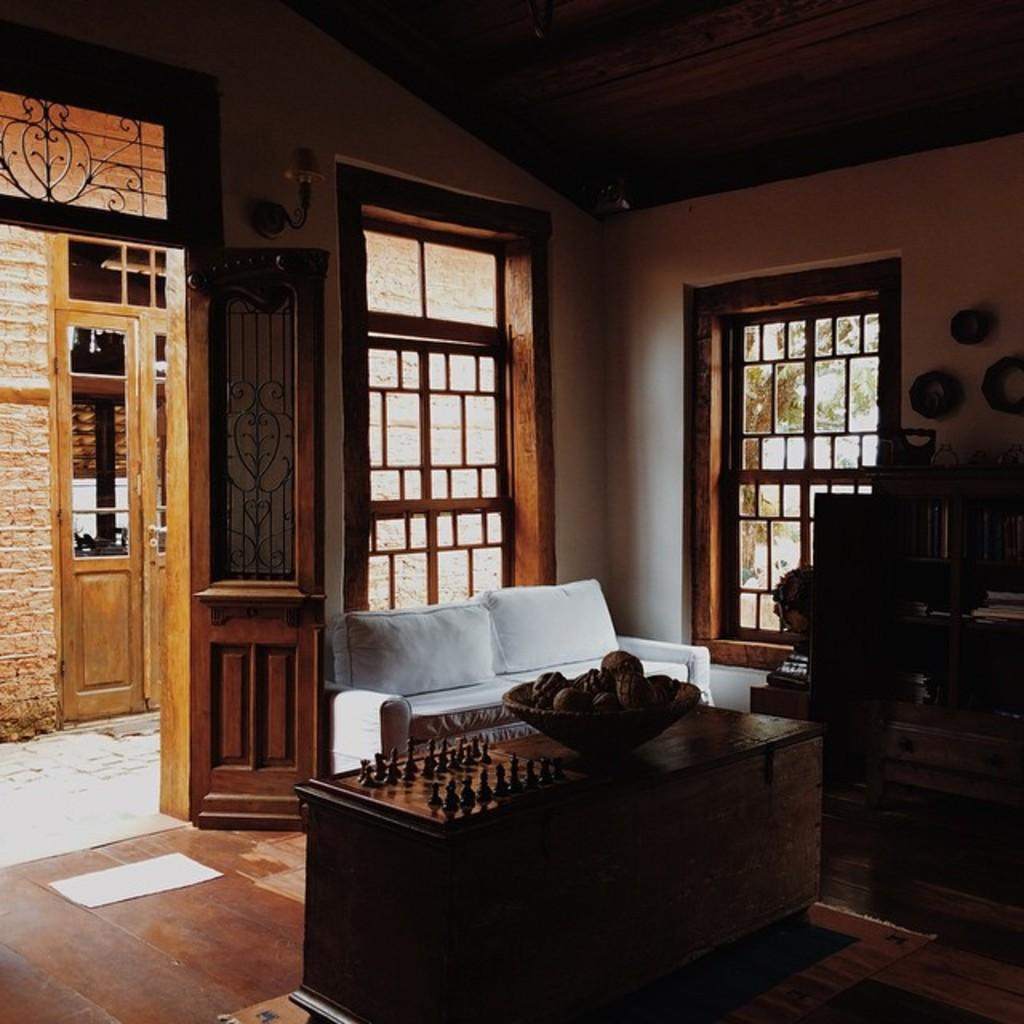What type of seating is available in the room? There is a sofa with pillows in the room. What other furniture is present in the room? There is a table in the room. What can be found on the table? There is a bowl of fruits on the table. What is located behind the bowl of fruits? There is a chess board behind the bowl of fruits. What type of storage is available in the room? There is a bookshelf with books in the room. How many people are in the crowd gathered around the chess board in the image? There is no crowd present in the image; it only shows a chess board behind a bowl of fruits on a table. 